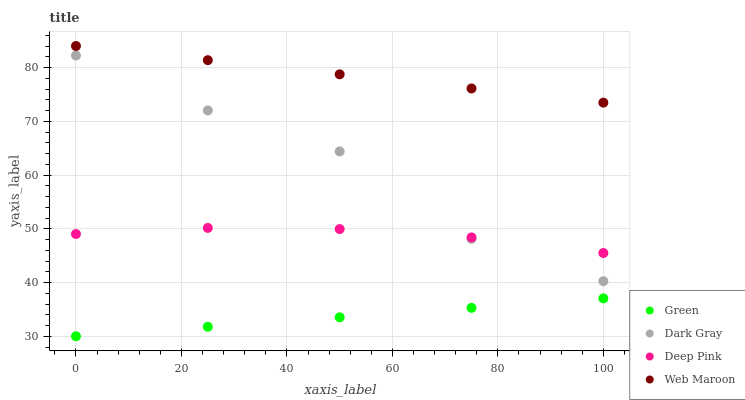Does Green have the minimum area under the curve?
Answer yes or no. Yes. Does Web Maroon have the maximum area under the curve?
Answer yes or no. Yes. Does Deep Pink have the minimum area under the curve?
Answer yes or no. No. Does Deep Pink have the maximum area under the curve?
Answer yes or no. No. Is Green the smoothest?
Answer yes or no. Yes. Is Dark Gray the roughest?
Answer yes or no. Yes. Is Web Maroon the smoothest?
Answer yes or no. No. Is Web Maroon the roughest?
Answer yes or no. No. Does Green have the lowest value?
Answer yes or no. Yes. Does Deep Pink have the lowest value?
Answer yes or no. No. Does Web Maroon have the highest value?
Answer yes or no. Yes. Does Deep Pink have the highest value?
Answer yes or no. No. Is Dark Gray less than Web Maroon?
Answer yes or no. Yes. Is Dark Gray greater than Green?
Answer yes or no. Yes. Does Dark Gray intersect Deep Pink?
Answer yes or no. Yes. Is Dark Gray less than Deep Pink?
Answer yes or no. No. Is Dark Gray greater than Deep Pink?
Answer yes or no. No. Does Dark Gray intersect Web Maroon?
Answer yes or no. No. 